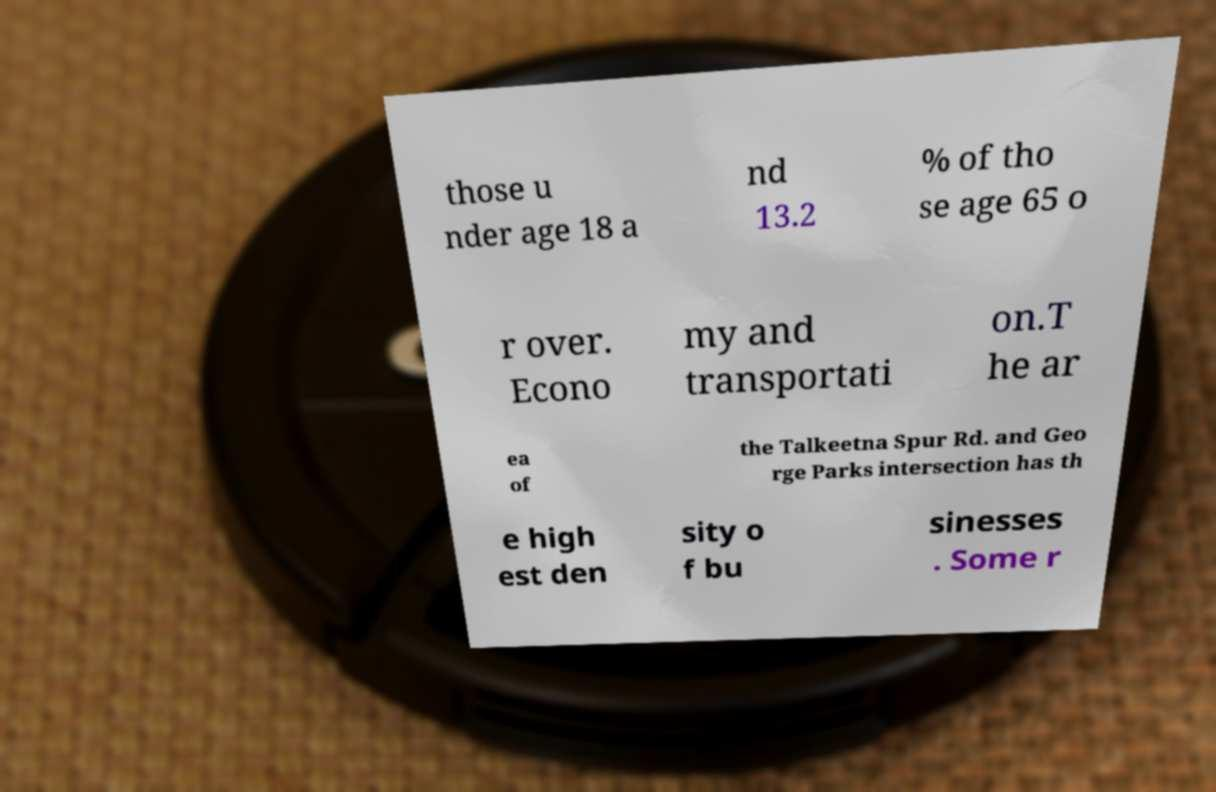Please read and relay the text visible in this image. What does it say? those u nder age 18 a nd 13.2 % of tho se age 65 o r over. Econo my and transportati on.T he ar ea of the Talkeetna Spur Rd. and Geo rge Parks intersection has th e high est den sity o f bu sinesses . Some r 